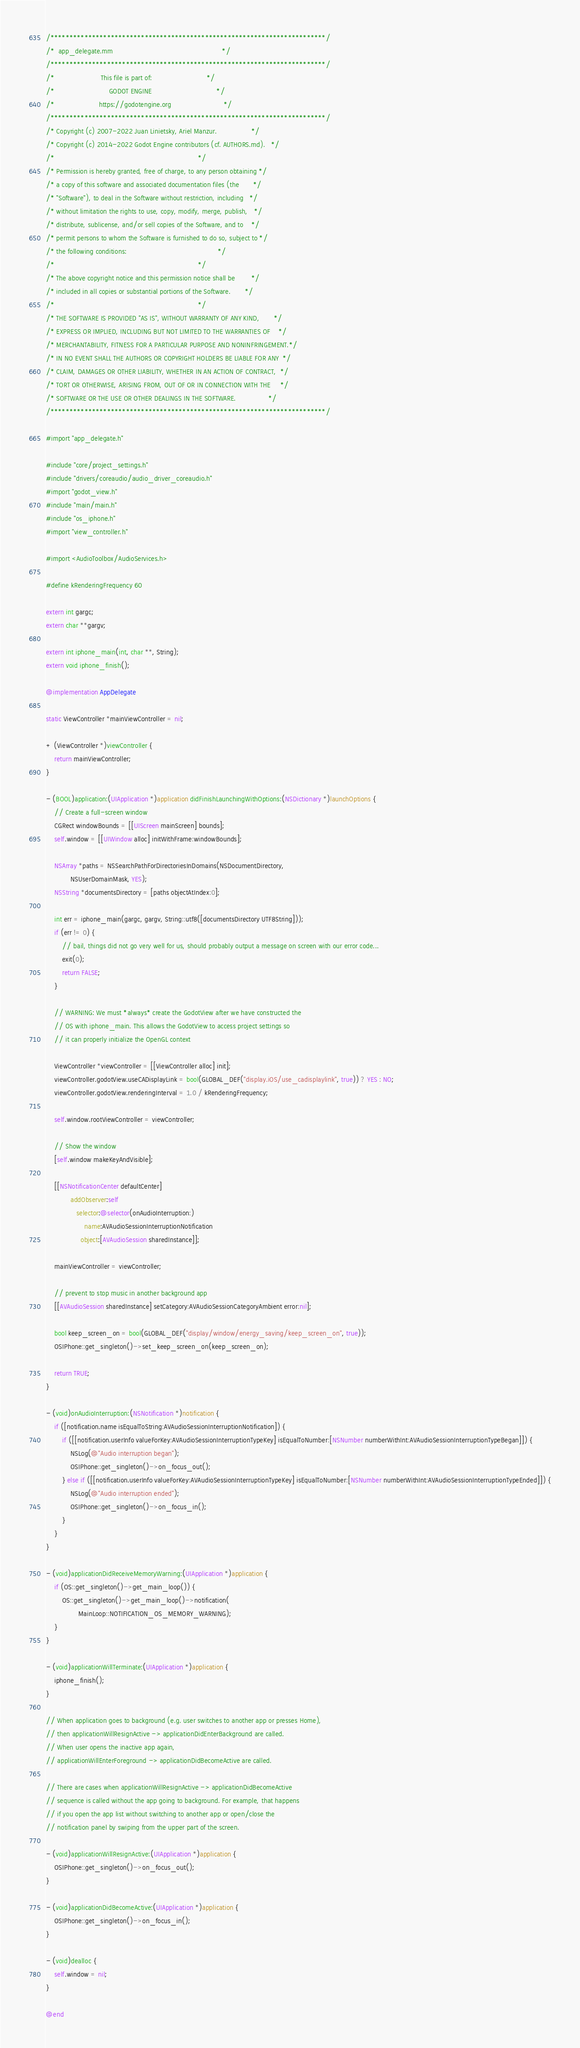<code> <loc_0><loc_0><loc_500><loc_500><_ObjectiveC_>/*************************************************************************/
/*  app_delegate.mm                                                      */
/*************************************************************************/
/*                       This file is part of:                           */
/*                           GODOT ENGINE                                */
/*                      https://godotengine.org                          */
/*************************************************************************/
/* Copyright (c) 2007-2022 Juan Linietsky, Ariel Manzur.                 */
/* Copyright (c) 2014-2022 Godot Engine contributors (cf. AUTHORS.md).   */
/*                                                                       */
/* Permission is hereby granted, free of charge, to any person obtaining */
/* a copy of this software and associated documentation files (the       */
/* "Software"), to deal in the Software without restriction, including   */
/* without limitation the rights to use, copy, modify, merge, publish,   */
/* distribute, sublicense, and/or sell copies of the Software, and to    */
/* permit persons to whom the Software is furnished to do so, subject to */
/* the following conditions:                                             */
/*                                                                       */
/* The above copyright notice and this permission notice shall be        */
/* included in all copies or substantial portions of the Software.       */
/*                                                                       */
/* THE SOFTWARE IS PROVIDED "AS IS", WITHOUT WARRANTY OF ANY KIND,       */
/* EXPRESS OR IMPLIED, INCLUDING BUT NOT LIMITED TO THE WARRANTIES OF    */
/* MERCHANTABILITY, FITNESS FOR A PARTICULAR PURPOSE AND NONINFRINGEMENT.*/
/* IN NO EVENT SHALL THE AUTHORS OR COPYRIGHT HOLDERS BE LIABLE FOR ANY  */
/* CLAIM, DAMAGES OR OTHER LIABILITY, WHETHER IN AN ACTION OF CONTRACT,  */
/* TORT OR OTHERWISE, ARISING FROM, OUT OF OR IN CONNECTION WITH THE     */
/* SOFTWARE OR THE USE OR OTHER DEALINGS IN THE SOFTWARE.                */
/*************************************************************************/

#import "app_delegate.h"

#include "core/project_settings.h"
#include "drivers/coreaudio/audio_driver_coreaudio.h"
#import "godot_view.h"
#include "main/main.h"
#include "os_iphone.h"
#import "view_controller.h"

#import <AudioToolbox/AudioServices.h>

#define kRenderingFrequency 60

extern int gargc;
extern char **gargv;

extern int iphone_main(int, char **, String);
extern void iphone_finish();

@implementation AppDelegate

static ViewController *mainViewController = nil;

+ (ViewController *)viewController {
	return mainViewController;
}

- (BOOL)application:(UIApplication *)application didFinishLaunchingWithOptions:(NSDictionary *)launchOptions {
	// Create a full-screen window
	CGRect windowBounds = [[UIScreen mainScreen] bounds];
	self.window = [[UIWindow alloc] initWithFrame:windowBounds];

	NSArray *paths = NSSearchPathForDirectoriesInDomains(NSDocumentDirectory,
			NSUserDomainMask, YES);
	NSString *documentsDirectory = [paths objectAtIndex:0];

	int err = iphone_main(gargc, gargv, String::utf8([documentsDirectory UTF8String]));
	if (err != 0) {
		// bail, things did not go very well for us, should probably output a message on screen with our error code...
		exit(0);
		return FALSE;
	}

	// WARNING: We must *always* create the GodotView after we have constructed the
	// OS with iphone_main. This allows the GodotView to access project settings so
	// it can properly initialize the OpenGL context

	ViewController *viewController = [[ViewController alloc] init];
	viewController.godotView.useCADisplayLink = bool(GLOBAL_DEF("display.iOS/use_cadisplaylink", true)) ? YES : NO;
	viewController.godotView.renderingInterval = 1.0 / kRenderingFrequency;

	self.window.rootViewController = viewController;

	// Show the window
	[self.window makeKeyAndVisible];

	[[NSNotificationCenter defaultCenter]
			addObserver:self
			   selector:@selector(onAudioInterruption:)
				   name:AVAudioSessionInterruptionNotification
				 object:[AVAudioSession sharedInstance]];

	mainViewController = viewController;

	// prevent to stop music in another background app
	[[AVAudioSession sharedInstance] setCategory:AVAudioSessionCategoryAmbient error:nil];

	bool keep_screen_on = bool(GLOBAL_DEF("display/window/energy_saving/keep_screen_on", true));
	OSIPhone::get_singleton()->set_keep_screen_on(keep_screen_on);

	return TRUE;
}

- (void)onAudioInterruption:(NSNotification *)notification {
	if ([notification.name isEqualToString:AVAudioSessionInterruptionNotification]) {
		if ([[notification.userInfo valueForKey:AVAudioSessionInterruptionTypeKey] isEqualToNumber:[NSNumber numberWithInt:AVAudioSessionInterruptionTypeBegan]]) {
			NSLog(@"Audio interruption began");
			OSIPhone::get_singleton()->on_focus_out();
		} else if ([[notification.userInfo valueForKey:AVAudioSessionInterruptionTypeKey] isEqualToNumber:[NSNumber numberWithInt:AVAudioSessionInterruptionTypeEnded]]) {
			NSLog(@"Audio interruption ended");
			OSIPhone::get_singleton()->on_focus_in();
		}
	}
}

- (void)applicationDidReceiveMemoryWarning:(UIApplication *)application {
	if (OS::get_singleton()->get_main_loop()) {
		OS::get_singleton()->get_main_loop()->notification(
				MainLoop::NOTIFICATION_OS_MEMORY_WARNING);
	}
}

- (void)applicationWillTerminate:(UIApplication *)application {
	iphone_finish();
}

// When application goes to background (e.g. user switches to another app or presses Home),
// then applicationWillResignActive -> applicationDidEnterBackground are called.
// When user opens the inactive app again,
// applicationWillEnterForeground -> applicationDidBecomeActive are called.

// There are cases when applicationWillResignActive -> applicationDidBecomeActive
// sequence is called without the app going to background. For example, that happens
// if you open the app list without switching to another app or open/close the
// notification panel by swiping from the upper part of the screen.

- (void)applicationWillResignActive:(UIApplication *)application {
	OSIPhone::get_singleton()->on_focus_out();
}

- (void)applicationDidBecomeActive:(UIApplication *)application {
	OSIPhone::get_singleton()->on_focus_in();
}

- (void)dealloc {
	self.window = nil;
}

@end
</code> 